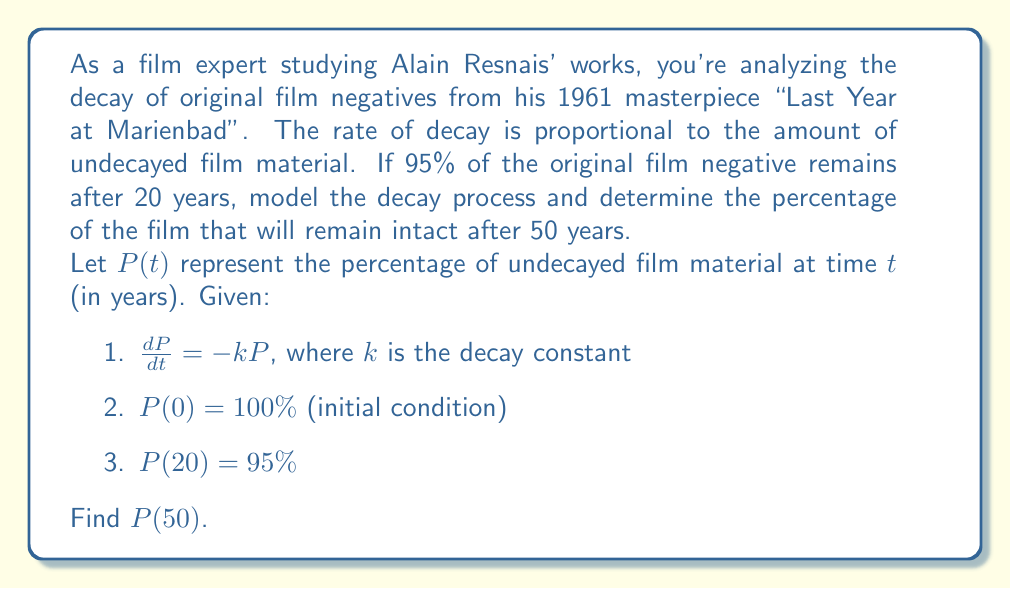Can you answer this question? To solve this first-order differential equation, we'll follow these steps:

1) The general solution to the differential equation $\frac{dP}{dt} = -kP$ is:

   $P(t) = Ce^{-kt}$

   where $C$ is a constant we'll determine using the initial condition.

2) Using the initial condition $P(0) = 100\%$:

   $100 = Ce^{-k(0)}$
   $100 = C$

3) So our specific solution is:

   $P(t) = 100e^{-kt}$

4) Now we can use the condition $P(20) = 95\%$ to find $k$:

   $95 = 100e^{-k(20)}$
   $0.95 = e^{-20k}$
   $\ln(0.95) = -20k$
   $k = -\frac{\ln(0.95)}{20} \approx 0.002565$

5) Now that we have $k$, we can find $P(50)$:

   $P(50) = 100e^{-0.002565(50)}$
   $P(50) = 100e^{-0.12825}$
   $P(50) = 100(0.8796)$
   $P(50) \approx 87.96\%$

Therefore, after 50 years, approximately 87.96% of the original film negative will remain intact.
Answer: $P(50) \approx 87.96\%$ 